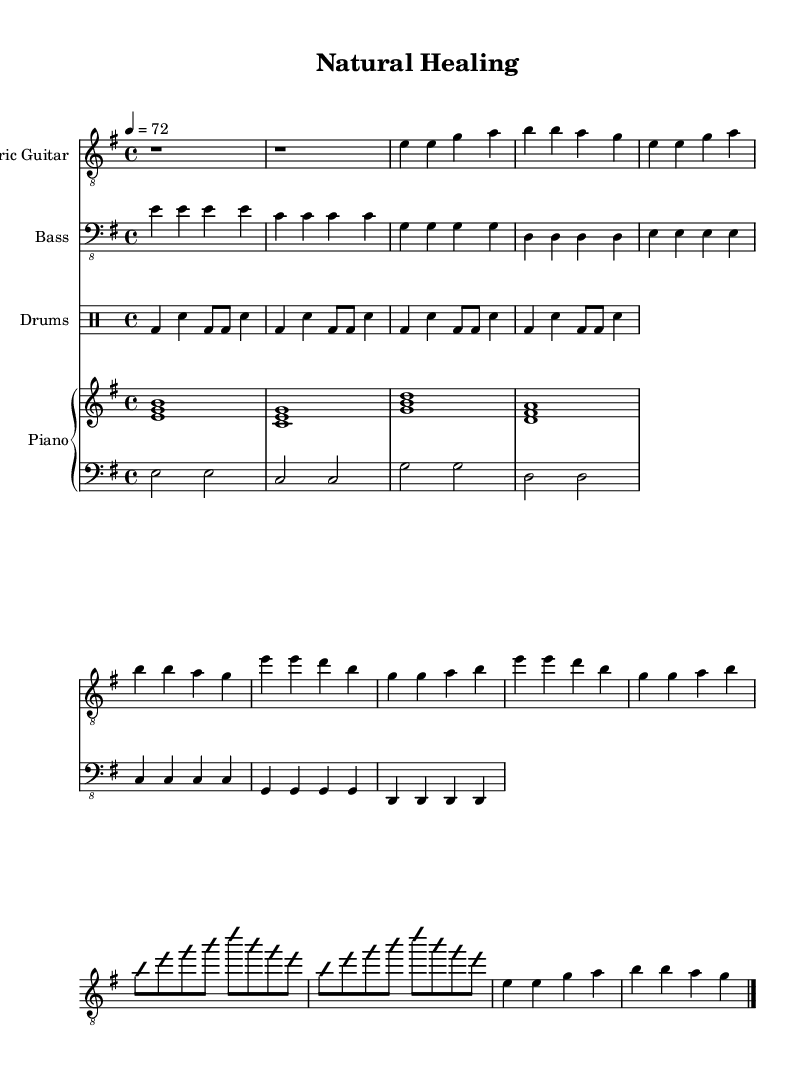What is the key signature of this music? The key signature is e minor, which has one sharp (F#). It can be determined by looking at the key signature notation at the beginning of the sheet music.
Answer: e minor What is the time signature of this music? The time signature is 4/4, indicated by the notation at the beginning of the piece. This means there are four beats in each measure and the quarter note gets one beat.
Answer: 4/4 What is the tempo marking for this piece? The tempo marking is 4 = 72, indicating that there are 72 beats per minute and each beat corresponds to a quarter note. This is found next to the tempo indication at the beginning of the sheet music.
Answer: 72 Which instrument has the melody in the verse section? The melody in the verse section is played by the electric guitar, which can be identified by its dedicated staff where the notes for the verse are notated.
Answer: Electric Guitar What is the rhythmic pattern for the drums in this score? The rhythmic pattern for the drums is a basic rock beat, consisting of bass drum and snare patterns repeated four times. This can be observed in the drum part written in the drummode section.
Answer: Basic rock beat What chords are used during the piano's right hand in the chorus? The chords played in the piano's right hand during the chorus are E major, D major, and G major, as indicated by the chord shapes in the sheet music. This is determined by examining the chord notes presented above the staff during the chorus section.
Answer: E major, D major, G major 